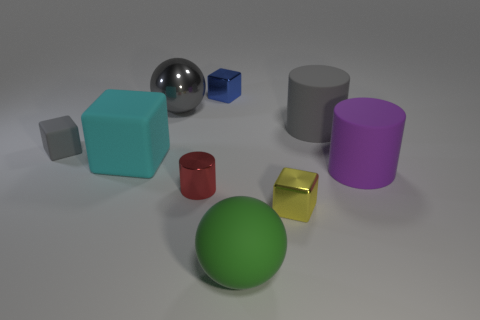Is there a brown matte block that has the same size as the purple matte object?
Provide a short and direct response. No. The other tiny cube that is made of the same material as the tiny yellow block is what color?
Offer a very short reply. Blue. What material is the blue block?
Your answer should be very brief. Metal. What is the shape of the blue thing?
Your answer should be compact. Cube. What number of large metal balls are the same color as the tiny rubber block?
Ensure brevity in your answer.  1. What material is the gray object right of the large ball that is right of the large ball behind the large gray rubber object?
Provide a short and direct response. Rubber. How many yellow things are metal objects or matte balls?
Offer a terse response. 1. There is a cylinder that is on the left side of the ball in front of the large ball that is behind the gray matte cylinder; what is its size?
Give a very brief answer. Small. What is the size of the yellow metal object that is the same shape as the blue metal thing?
Offer a very short reply. Small. How many big objects are either yellow blocks or cyan matte things?
Offer a terse response. 1. 